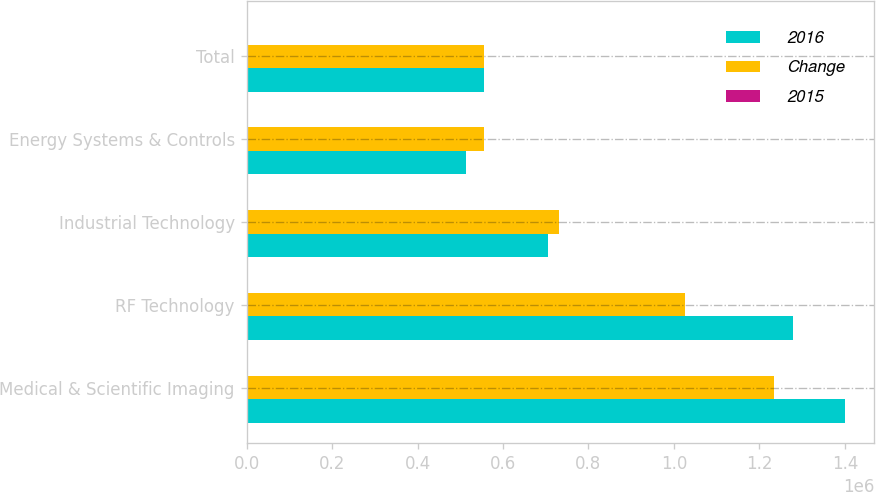Convert chart. <chart><loc_0><loc_0><loc_500><loc_500><stacked_bar_chart><ecel><fcel>Medical & Scientific Imaging<fcel>RF Technology<fcel>Industrial Technology<fcel>Energy Systems & Controls<fcel>Total<nl><fcel>2016<fcel>1.39901e+06<fcel>1.27825e+06<fcel>704622<fcel>514300<fcel>555672<nl><fcel>Change<fcel>1.23514e+06<fcel>1.025e+06<fcel>731810<fcel>555672<fcel>555672<nl><fcel>2015<fcel>13.3<fcel>24.7<fcel>3.7<fcel>7.4<fcel>9.8<nl></chart> 